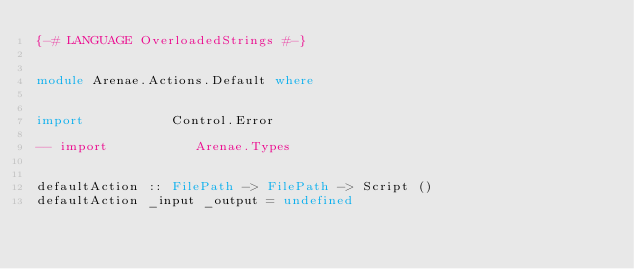Convert code to text. <code><loc_0><loc_0><loc_500><loc_500><_Haskell_>{-# LANGUAGE OverloadedStrings #-}


module Arenae.Actions.Default where


import           Control.Error

-- import           Arenae.Types


defaultAction :: FilePath -> FilePath -> Script ()
defaultAction _input _output = undefined</code> 